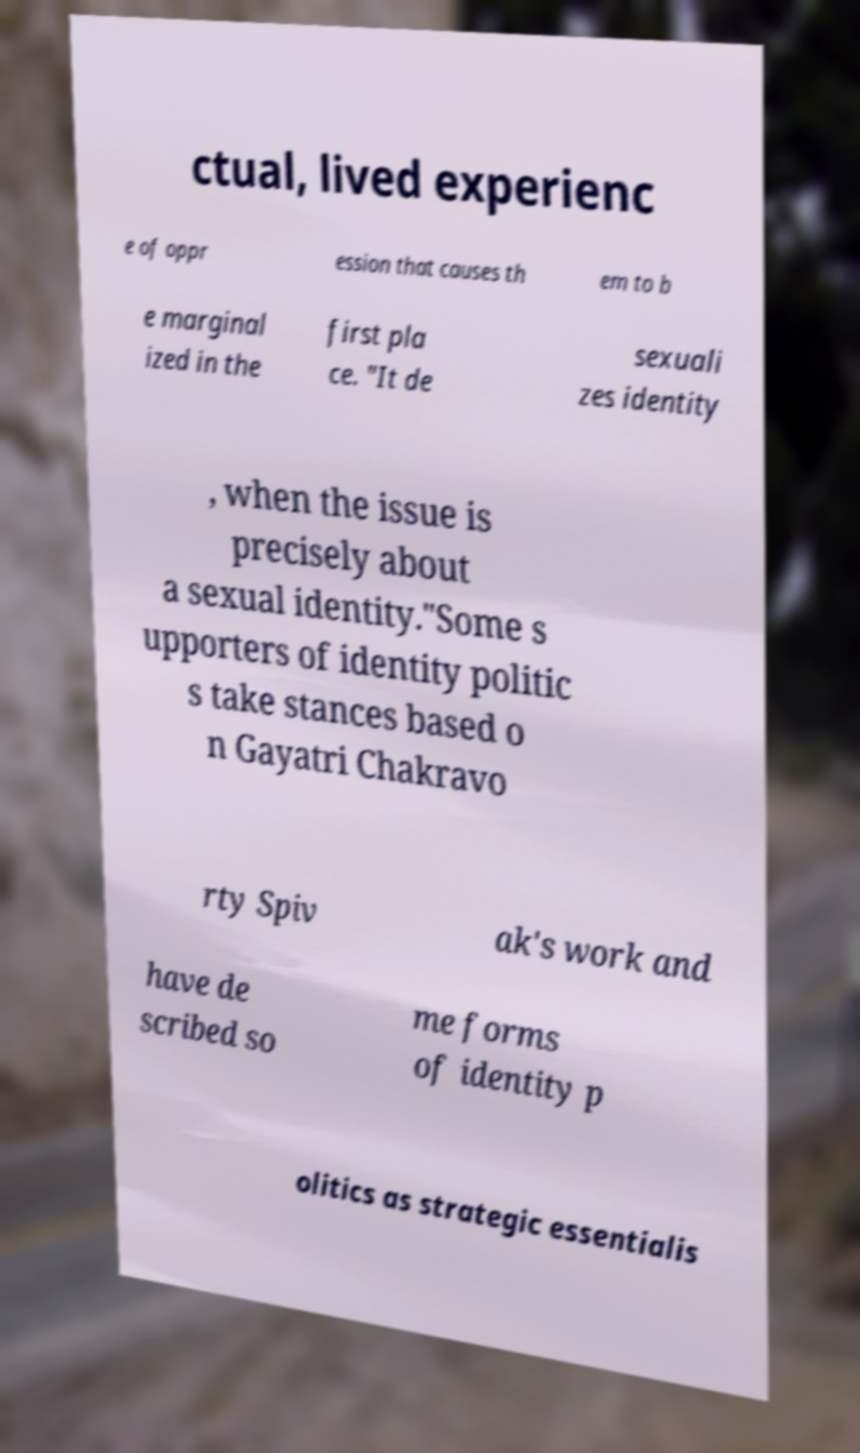Can you read and provide the text displayed in the image?This photo seems to have some interesting text. Can you extract and type it out for me? ctual, lived experienc e of oppr ession that causes th em to b e marginal ized in the first pla ce. "It de sexuali zes identity , when the issue is precisely about a sexual identity."Some s upporters of identity politic s take stances based o n Gayatri Chakravo rty Spiv ak's work and have de scribed so me forms of identity p olitics as strategic essentialis 